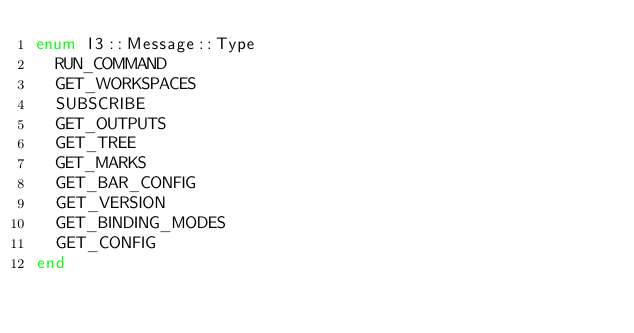<code> <loc_0><loc_0><loc_500><loc_500><_Crystal_>enum I3::Message::Type
  RUN_COMMAND
  GET_WORKSPACES
  SUBSCRIBE
  GET_OUTPUTS
  GET_TREE
  GET_MARKS
  GET_BAR_CONFIG
  GET_VERSION
  GET_BINDING_MODES
  GET_CONFIG
end
</code> 